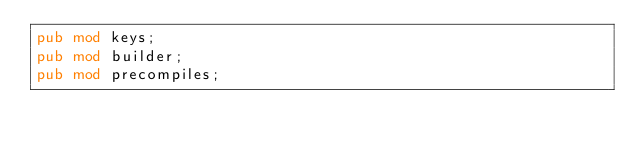<code> <loc_0><loc_0><loc_500><loc_500><_Rust_>pub mod keys;
pub mod builder;
pub mod precompiles;
</code> 